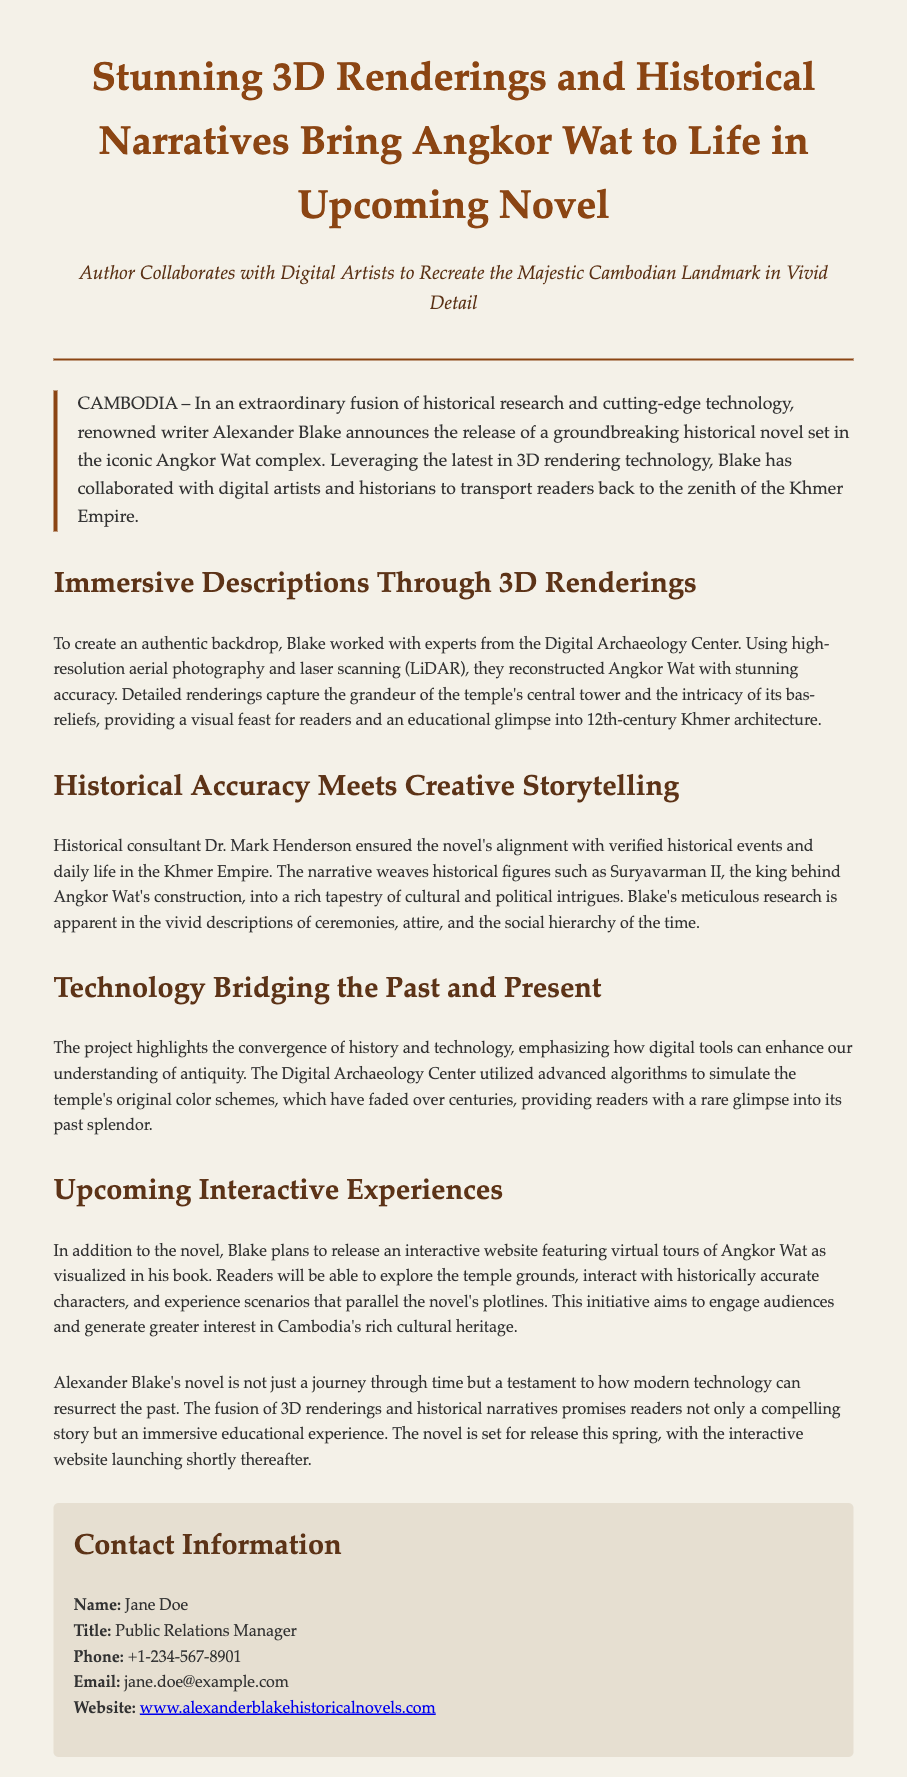What is the name of the author? The author's name is mentioned at the beginning of the press release.
Answer: Alexander Blake What is the title of the press release? The title appears at the top of the document and summarizes the main topic.
Answer: Stunning 3D Renderings and Historical Narratives Bring Angkor Wat to Life in Upcoming Novel Who is the historical consultant for the novel? The document specifies who ensured the historical accuracy of the novel.
Answer: Dr. Mark Henderson What technology was used to create the renderings? The document describes the technology leveraged for the renderings and gives its name.
Answer: 3D rendering technology What is the planned release season for the novel? The press release mentions the timing of the novel's release.
Answer: Spring What will the interactive website feature? The document outlines what readers can expect to find on the upcoming interactive website.
Answer: Virtual tours of Angkor Wat Which complex is being focused on in the novel? The product of the novel is highlighted prominently in the press release.
Answer: Angkor Wat What was simulated to provide a glimpse into Angkor Wat's past? The press release explains what advanced algorithms simulated for historical representation.
Answer: Original color schemes How is the project described in terms of the relationship between history and technology? The document describes a key characteristic of the project itself.
Answer: Convergence of history and technology 